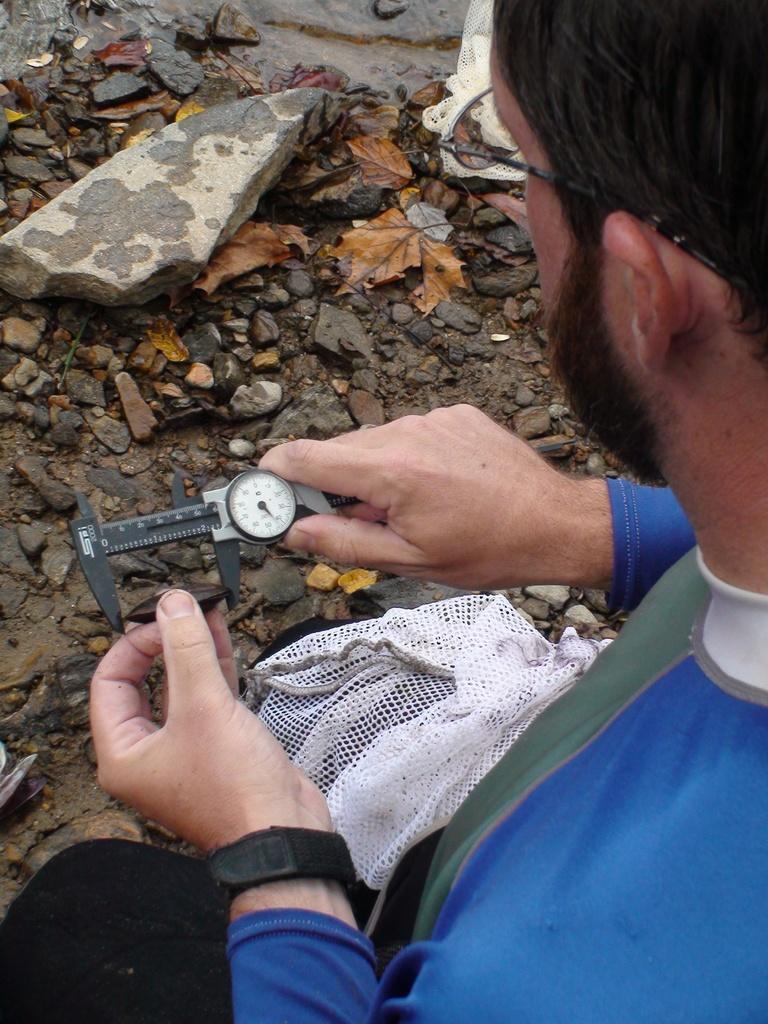In one or two sentences, can you explain what this image depicts? In this image we can see a person wearing a blue dress and spectacles is holding a device in his hand. In the background, we can see group of stones and a bag. 